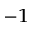Convert formula to latex. <formula><loc_0><loc_0><loc_500><loc_500>^ { - 1 }</formula> 